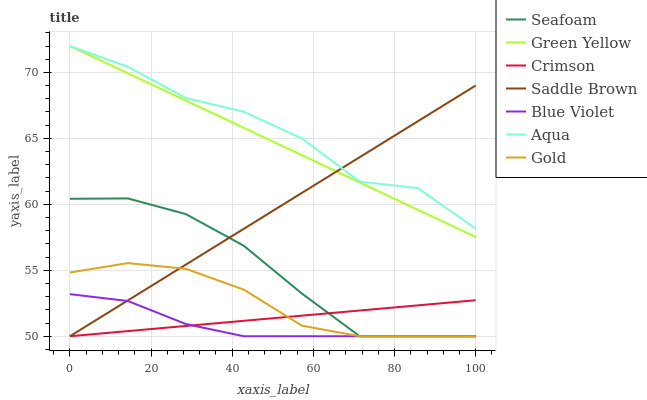Does Blue Violet have the minimum area under the curve?
Answer yes or no. Yes. Does Aqua have the maximum area under the curve?
Answer yes or no. Yes. Does Seafoam have the minimum area under the curve?
Answer yes or no. No. Does Seafoam have the maximum area under the curve?
Answer yes or no. No. Is Crimson the smoothest?
Answer yes or no. Yes. Is Aqua the roughest?
Answer yes or no. Yes. Is Seafoam the smoothest?
Answer yes or no. No. Is Seafoam the roughest?
Answer yes or no. No. Does Gold have the lowest value?
Answer yes or no. Yes. Does Aqua have the lowest value?
Answer yes or no. No. Does Green Yellow have the highest value?
Answer yes or no. Yes. Does Seafoam have the highest value?
Answer yes or no. No. Is Crimson less than Green Yellow?
Answer yes or no. Yes. Is Green Yellow greater than Seafoam?
Answer yes or no. Yes. Does Blue Violet intersect Seafoam?
Answer yes or no. Yes. Is Blue Violet less than Seafoam?
Answer yes or no. No. Is Blue Violet greater than Seafoam?
Answer yes or no. No. Does Crimson intersect Green Yellow?
Answer yes or no. No. 